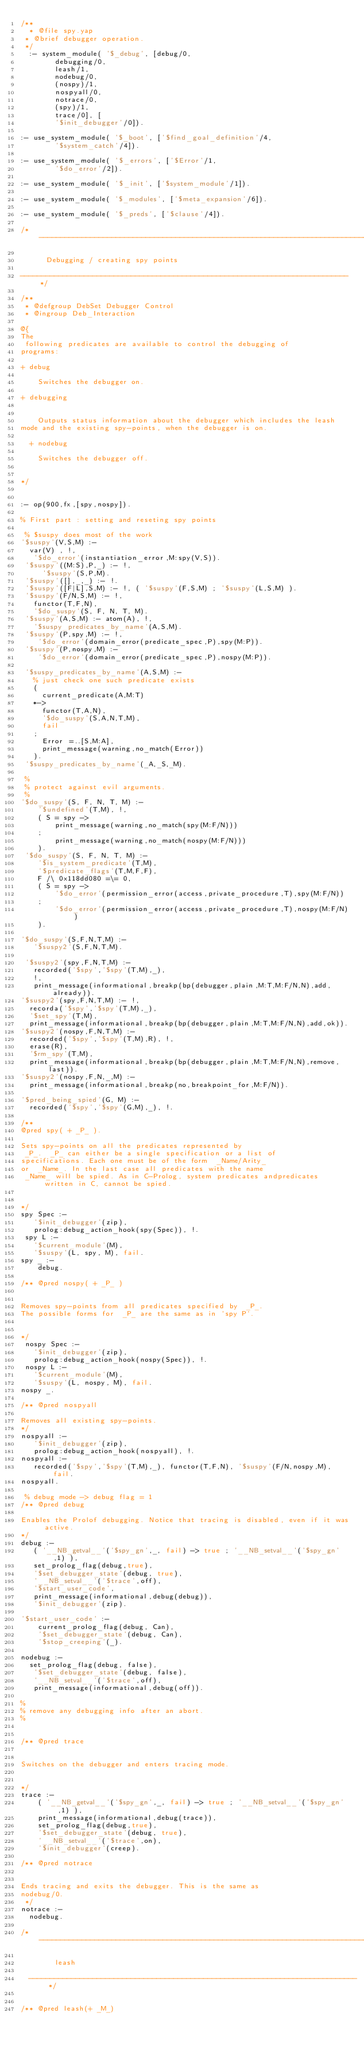<code> <loc_0><loc_0><loc_500><loc_500><_Prolog_>/**
  * @file spy.yap
 * @brief debugger operation.
 */
  :- system_module( '$_debug', [debug/0,
        debugging/0,
        leash/1,
        nodebug/0,
        (nospy)/1,
        nospyall/0,
        notrace/0,
        (spy)/1,
        trace/0], [
        '$init_debugger'/0]).

:- use_system_module( '$_boot', ['$find_goal_definition'/4,
        '$system_catch'/4]).

:- use_system_module( '$_errors', ['$Error'/1,
        '$do_error'/2]).

:- use_system_module( '$_init', ['$system_module'/1]).

:- use_system_module( '$_modules', ['$meta_expansion'/6]).

:- use_system_module( '$_preds', ['$clause'/4]).

/*-----------------------------------------------------------------------------

			Debugging / creating spy points

-----------------------------------------------------------------------------*/

/**
 * @defgroup DebSet Debugger Control
 * @ingroup Deb_Interaction

@{
The
 following predicates are available to control the debugging of
programs:

+ debug

    Switches the debugger on.

+ debugging


    Outputs status information about the debugger which includes the leash
mode and the existing spy-points, when the debugger is on.

  + nodebug

    Switches the debugger off.


*/


:- op(900,fx,[spy,nospy]).

% First part : setting and reseting spy points

 % $suspy does most of the work
'$suspy'(V,S,M) :-
	var(V) , !,
	 '$do_error'(instantiation_error,M:spy(V,S)).
 '$suspy'((M:S),P,_) :- !,
     '$suspy'(S,P,M).
 '$suspy'([],_,_) :- !.
 '$suspy'([F|L],S,M) :- !, ( '$suspy'(F,S,M) ; '$suspy'(L,S,M) ).
 '$suspy'(F/N,S,M) :- !,
	 functor(T,F,N),
	 '$do_suspy'(S, F, N, T, M).
 '$suspy'(A,S,M) :- atom(A), !,
	 '$suspy_predicates_by_name'(A,S,M).
 '$suspy'(P,spy,M) :- !,
	  '$do_error'(domain_error(predicate_spec,P),spy(M:P)).
 '$suspy'(P,nospy,M) :-
	  '$do_error'(domain_error(predicate_spec,P),nospy(M:P)).

 '$suspy_predicates_by_name'(A,S,M) :-
	 % just check one such predicate exists
	 (
	   current_predicate(A,M:T)
	 *->
	   functor(T,A,N),
	   '$do_suspy'(S,A,N,T,M),
	   fail
	 ;
	   Error =..[S,M:A],
	   print_message(warning,no_match(Error))
	 ).
 '$suspy_predicates_by_name'(_A,_S,_M).

 %
 % protect against evil arguments.
 %
'$do_suspy'(S, F, N, T, M) :-
	  '$undefined'(T,M), !,
	  ( S = spy ->
	      print_message(warning,no_match(spy(M:F/N)))
	  ;
	      print_message(warning,no_match(nospy(M:F/N)))
	  ).
 '$do_suspy'(S, F, N, T, M) :-
	  '$is_system_predicate'(T,M),
	  '$predicate_flags'(T,M,F,F),
	  F /\ 0x118dd080 =\= 0,
	  ( S = spy ->
	      '$do_error'(permission_error(access,private_procedure,T),spy(M:F/N))
	  ;
	      '$do_error'(permission_error(access,private_procedure,T),nospy(M:F/N))
	  ).

'$do_suspy'(S,F,N,T,M) :-
	 '$suspy2'(S,F,N,T,M).

 '$suspy2'(spy,F,N,T,M) :-
	 recorded('$spy','$spy'(T,M),_),
	 !,
	 print_message(informational,breakp(bp(debugger,plain,M:T,M:F/N,N),add,already)).
'$suspy2'(spy,F,N,T,M) :- !,
	recorda('$spy','$spy'(T,M),_),
	'$set_spy'(T,M),
	print_message(informational,breakp(bp(debugger,plain,M:T,M:F/N,N),add,ok)).
'$suspy2'(nospy,F,N,T,M) :-
	recorded('$spy','$spy'(T,M),R), !,
	erase(R),
	'$rm_spy'(T,M),
	print_message(informational,breakp(bp(debugger,plain,M:T,M:F/N,N),remove,last)).
'$suspy2'(nospy,F,N,_,M) :-
	print_message(informational,breakp(no,breakpoint_for,M:F/N)).

'$pred_being_spied'(G, M) :-
	recorded('$spy','$spy'(G,M),_), !.

/**
@pred spy( + _P_ ).

Sets spy-points on all the predicates represented by
 _P_.  _P_ can either be a single specification or a list of
specifications. Each one must be of the form  _Name/Arity_
or  _Name_. In the last case all predicates with the name
 _Name_ will be spied. As in C-Prolog, system predicates andpredicates written in C, cannot be spied.


*/
spy Spec :-
	 '$init_debugger'(zip),
	 prolog:debug_action_hook(spy(Spec)), !.
 spy L :-
	 '$current_module'(M),
	 '$suspy'(L, spy, M), fail.
spy _ :-
    debug.

/** @pred nospy( + _P_ )


Removes spy-points from all predicates specified by  _P_.
The possible forms for  _P_ are the same as in `spy P`.


*/
 nospy Spec :-
	 '$init_debugger'(zip),
	 prolog:debug_action_hook(nospy(Spec)), !.
 nospy L :-
	 '$current_module'(M),
	 '$suspy'(L, nospy, M), fail.
nospy _.

/** @pred nospyall

Removes all existing spy-points.
*/
nospyall :-
	 '$init_debugger'(zip),
	 prolog:debug_action_hook(nospyall), !.
nospyall :-
	 recorded('$spy','$spy'(T,M),_), functor(T,F,N), '$suspy'(F/N,nospy,M), fail.
nospyall.

 % debug mode -> debug flag = 1
/** @pred debug

Enables the Prolof debugging. Notice that tracing is disabled, even if it was active.
*/
debug :-
	 ( '__NB_getval__'('$spy_gn',_, fail) -> true ; '__NB_setval__'('$spy_gn',1) ),
	 set_prolog_flag(debug,true),
	 '$set_debugger_state'(debug, true),
	 '__NB_setval__'('$trace',off),
	 '$start_user_code',
	 print_message(informational,debug(debug)),
	 '$init_debugger'(zip).

'$start_user_code' :-
    current_prolog_flag(debug, Can),
    '$set_debugger_state'(debug, Can),
    '$stop_creeping'(_).

nodebug :-
	set_prolog_flag(debug, false),
	 '$set_debugger_state'(debug, false),
	 '__NB_setval__'('$trace',off),
	 print_message(informational,debug(off)).

%
% remove any debugging info after an abort.
%


/** @pred trace


Switches on the debugger and enters tracing mode.


*/
trace :-
    ( '__NB_getval__'('$spy_gn',_, fail) -> true ; '__NB_setval__'('$spy_gn',1) ),
    print_message(informational,debug(trace)),
    set_prolog_flag(debug,true),
    '$set_debugger_state'(debug, true),
    '__NB_setval__'('$trace',on),
    '$init_debugger'(creep).

/** @pred notrace


Ends tracing and exits the debugger. This is the same as
nodebug/0.
 */
notrace :-
	nodebug.

/*-----------------------------------------------------------------------------

				leash

  -----------------------------------------------------------------------------*/


/** @pred leash(+ _M_)

</code> 